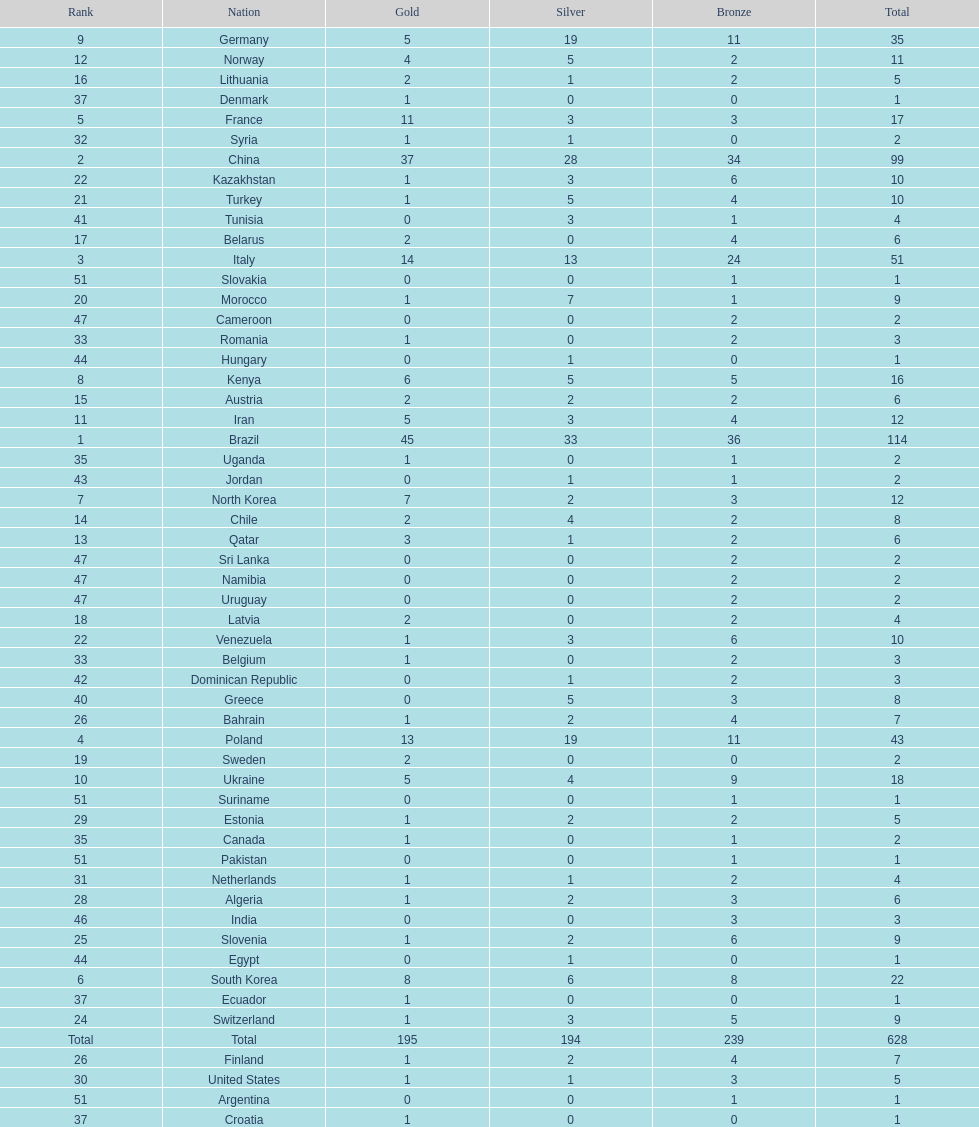What is the total number of medals between south korea, north korea, sweden, and brazil? 150. Parse the full table. {'header': ['Rank', 'Nation', 'Gold', 'Silver', 'Bronze', 'Total'], 'rows': [['9', 'Germany', '5', '19', '11', '35'], ['12', 'Norway', '4', '5', '2', '11'], ['16', 'Lithuania', '2', '1', '2', '5'], ['37', 'Denmark', '1', '0', '0', '1'], ['5', 'France', '11', '3', '3', '17'], ['32', 'Syria', '1', '1', '0', '2'], ['2', 'China', '37', '28', '34', '99'], ['22', 'Kazakhstan', '1', '3', '6', '10'], ['21', 'Turkey', '1', '5', '4', '10'], ['41', 'Tunisia', '0', '3', '1', '4'], ['17', 'Belarus', '2', '0', '4', '6'], ['3', 'Italy', '14', '13', '24', '51'], ['51', 'Slovakia', '0', '0', '1', '1'], ['20', 'Morocco', '1', '7', '1', '9'], ['47', 'Cameroon', '0', '0', '2', '2'], ['33', 'Romania', '1', '0', '2', '3'], ['44', 'Hungary', '0', '1', '0', '1'], ['8', 'Kenya', '6', '5', '5', '16'], ['15', 'Austria', '2', '2', '2', '6'], ['11', 'Iran', '5', '3', '4', '12'], ['1', 'Brazil', '45', '33', '36', '114'], ['35', 'Uganda', '1', '0', '1', '2'], ['43', 'Jordan', '0', '1', '1', '2'], ['7', 'North Korea', '7', '2', '3', '12'], ['14', 'Chile', '2', '4', '2', '8'], ['13', 'Qatar', '3', '1', '2', '6'], ['47', 'Sri Lanka', '0', '0', '2', '2'], ['47', 'Namibia', '0', '0', '2', '2'], ['47', 'Uruguay', '0', '0', '2', '2'], ['18', 'Latvia', '2', '0', '2', '4'], ['22', 'Venezuela', '1', '3', '6', '10'], ['33', 'Belgium', '1', '0', '2', '3'], ['42', 'Dominican Republic', '0', '1', '2', '3'], ['40', 'Greece', '0', '5', '3', '8'], ['26', 'Bahrain', '1', '2', '4', '7'], ['4', 'Poland', '13', '19', '11', '43'], ['19', 'Sweden', '2', '0', '0', '2'], ['10', 'Ukraine', '5', '4', '9', '18'], ['51', 'Suriname', '0', '0', '1', '1'], ['29', 'Estonia', '1', '2', '2', '5'], ['35', 'Canada', '1', '0', '1', '2'], ['51', 'Pakistan', '0', '0', '1', '1'], ['31', 'Netherlands', '1', '1', '2', '4'], ['28', 'Algeria', '1', '2', '3', '6'], ['46', 'India', '0', '0', '3', '3'], ['25', 'Slovenia', '1', '2', '6', '9'], ['44', 'Egypt', '0', '1', '0', '1'], ['6', 'South Korea', '8', '6', '8', '22'], ['37', 'Ecuador', '1', '0', '0', '1'], ['24', 'Switzerland', '1', '3', '5', '9'], ['Total', 'Total', '195', '194', '239', '628'], ['26', 'Finland', '1', '2', '4', '7'], ['30', 'United States', '1', '1', '3', '5'], ['51', 'Argentina', '0', '0', '1', '1'], ['37', 'Croatia', '1', '0', '0', '1']]} 